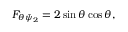Convert formula to latex. <formula><loc_0><loc_0><loc_500><loc_500>F _ { \theta \bar { \psi } _ { 2 } } = 2 \sin \theta \cos \theta ,</formula> 